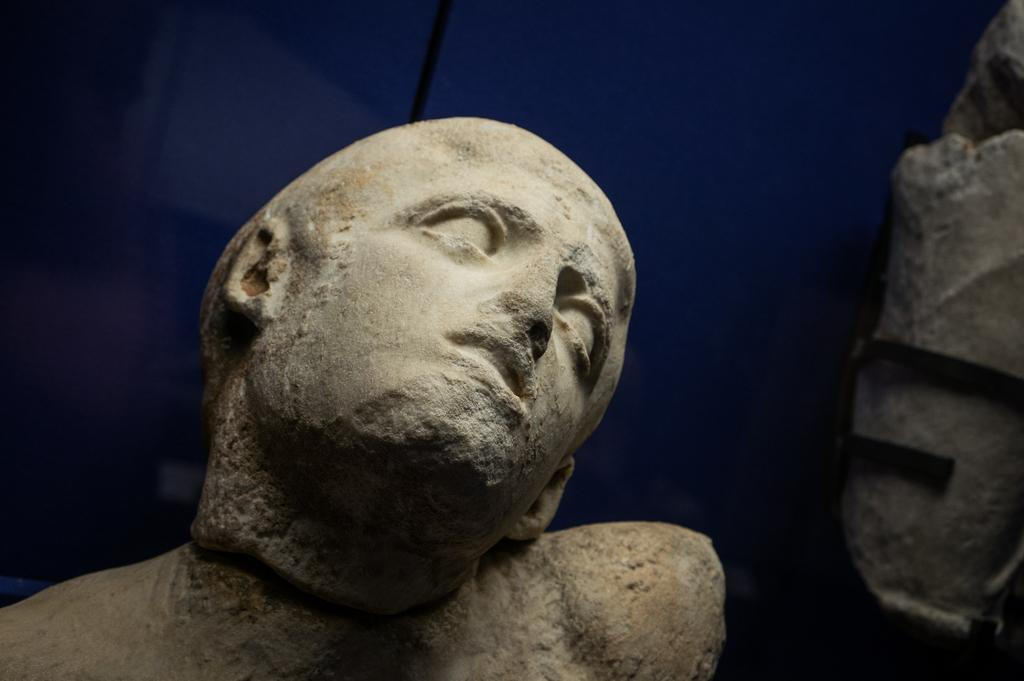What type of art is featured in the image? There are sculptures in the image. Can you describe the background of the image? There appears to be a cloth in the background of the image. What type of tooth is visible in the image? There is no tooth present in the image; it features sculptures and a cloth in the background. 